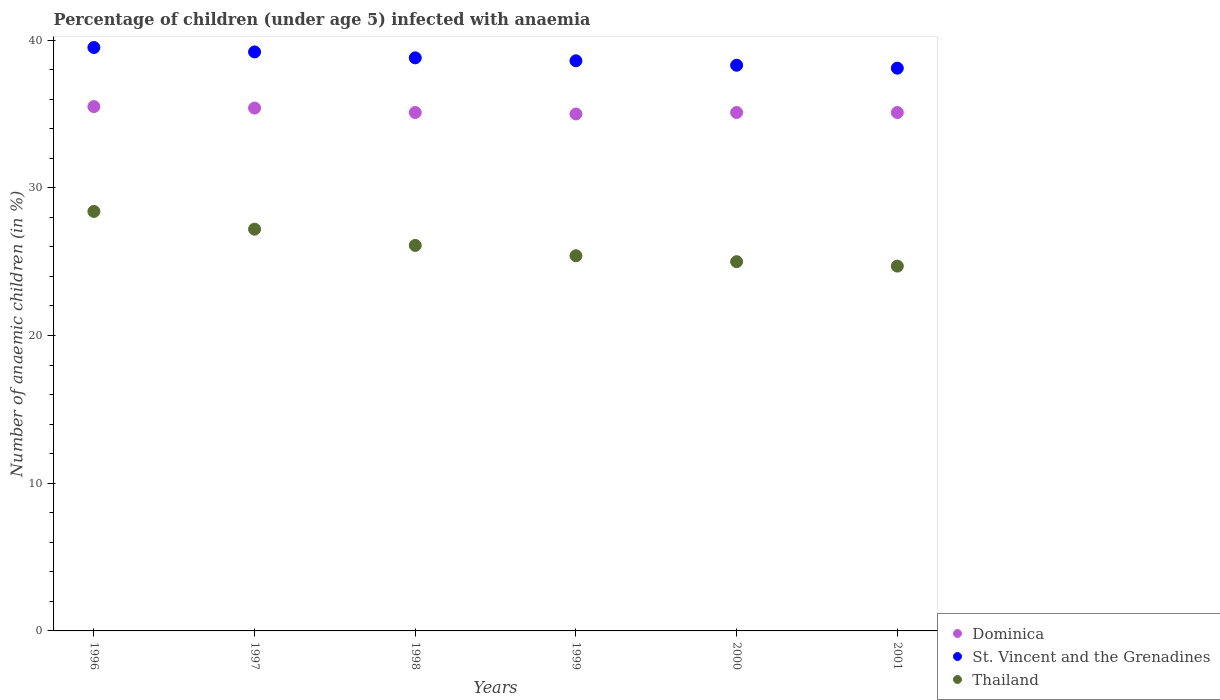How many different coloured dotlines are there?
Your answer should be very brief. 3. What is the percentage of children infected with anaemia in in Dominica in 1997?
Your response must be concise. 35.4. Across all years, what is the maximum percentage of children infected with anaemia in in St. Vincent and the Grenadines?
Your answer should be compact. 39.5. Across all years, what is the minimum percentage of children infected with anaemia in in Thailand?
Provide a succinct answer. 24.7. What is the total percentage of children infected with anaemia in in Thailand in the graph?
Offer a very short reply. 156.8. What is the difference between the percentage of children infected with anaemia in in Thailand in 1996 and that in 2001?
Give a very brief answer. 3.7. What is the difference between the percentage of children infected with anaemia in in Dominica in 1999 and the percentage of children infected with anaemia in in Thailand in 1996?
Offer a terse response. 6.6. What is the average percentage of children infected with anaemia in in St. Vincent and the Grenadines per year?
Offer a very short reply. 38.75. In the year 2001, what is the difference between the percentage of children infected with anaemia in in Thailand and percentage of children infected with anaemia in in St. Vincent and the Grenadines?
Make the answer very short. -13.4. In how many years, is the percentage of children infected with anaemia in in Dominica greater than 4 %?
Your response must be concise. 6. Is the difference between the percentage of children infected with anaemia in in Thailand in 1998 and 1999 greater than the difference between the percentage of children infected with anaemia in in St. Vincent and the Grenadines in 1998 and 1999?
Your answer should be very brief. Yes. What is the difference between the highest and the second highest percentage of children infected with anaemia in in Dominica?
Offer a very short reply. 0.1. What is the difference between the highest and the lowest percentage of children infected with anaemia in in Thailand?
Give a very brief answer. 3.7. Is the percentage of children infected with anaemia in in Thailand strictly less than the percentage of children infected with anaemia in in St. Vincent and the Grenadines over the years?
Provide a succinct answer. Yes. What is the difference between two consecutive major ticks on the Y-axis?
Give a very brief answer. 10. Are the values on the major ticks of Y-axis written in scientific E-notation?
Ensure brevity in your answer.  No. Does the graph contain any zero values?
Make the answer very short. No. Where does the legend appear in the graph?
Offer a terse response. Bottom right. How are the legend labels stacked?
Your answer should be compact. Vertical. What is the title of the graph?
Offer a very short reply. Percentage of children (under age 5) infected with anaemia. Does "Portugal" appear as one of the legend labels in the graph?
Your answer should be compact. No. What is the label or title of the Y-axis?
Offer a very short reply. Number of anaemic children (in %). What is the Number of anaemic children (in %) in Dominica in 1996?
Your answer should be compact. 35.5. What is the Number of anaemic children (in %) in St. Vincent and the Grenadines in 1996?
Provide a short and direct response. 39.5. What is the Number of anaemic children (in %) of Thailand in 1996?
Provide a short and direct response. 28.4. What is the Number of anaemic children (in %) of Dominica in 1997?
Provide a succinct answer. 35.4. What is the Number of anaemic children (in %) of St. Vincent and the Grenadines in 1997?
Your answer should be compact. 39.2. What is the Number of anaemic children (in %) of Thailand in 1997?
Provide a short and direct response. 27.2. What is the Number of anaemic children (in %) of Dominica in 1998?
Give a very brief answer. 35.1. What is the Number of anaemic children (in %) of St. Vincent and the Grenadines in 1998?
Your response must be concise. 38.8. What is the Number of anaemic children (in %) of Thailand in 1998?
Make the answer very short. 26.1. What is the Number of anaemic children (in %) of St. Vincent and the Grenadines in 1999?
Provide a succinct answer. 38.6. What is the Number of anaemic children (in %) in Thailand in 1999?
Ensure brevity in your answer.  25.4. What is the Number of anaemic children (in %) in Dominica in 2000?
Your response must be concise. 35.1. What is the Number of anaemic children (in %) of St. Vincent and the Grenadines in 2000?
Your answer should be compact. 38.3. What is the Number of anaemic children (in %) in Dominica in 2001?
Offer a terse response. 35.1. What is the Number of anaemic children (in %) in St. Vincent and the Grenadines in 2001?
Give a very brief answer. 38.1. What is the Number of anaemic children (in %) of Thailand in 2001?
Provide a succinct answer. 24.7. Across all years, what is the maximum Number of anaemic children (in %) of Dominica?
Offer a very short reply. 35.5. Across all years, what is the maximum Number of anaemic children (in %) in St. Vincent and the Grenadines?
Keep it short and to the point. 39.5. Across all years, what is the maximum Number of anaemic children (in %) in Thailand?
Your answer should be compact. 28.4. Across all years, what is the minimum Number of anaemic children (in %) of St. Vincent and the Grenadines?
Make the answer very short. 38.1. Across all years, what is the minimum Number of anaemic children (in %) in Thailand?
Your answer should be compact. 24.7. What is the total Number of anaemic children (in %) of Dominica in the graph?
Your answer should be very brief. 211.2. What is the total Number of anaemic children (in %) of St. Vincent and the Grenadines in the graph?
Provide a succinct answer. 232.5. What is the total Number of anaemic children (in %) of Thailand in the graph?
Your answer should be very brief. 156.8. What is the difference between the Number of anaemic children (in %) in Dominica in 1996 and that in 1997?
Your answer should be compact. 0.1. What is the difference between the Number of anaemic children (in %) in St. Vincent and the Grenadines in 1996 and that in 1997?
Your answer should be compact. 0.3. What is the difference between the Number of anaemic children (in %) in Thailand in 1996 and that in 1997?
Offer a very short reply. 1.2. What is the difference between the Number of anaemic children (in %) in St. Vincent and the Grenadines in 1996 and that in 1999?
Your answer should be very brief. 0.9. What is the difference between the Number of anaemic children (in %) of Thailand in 1996 and that in 1999?
Keep it short and to the point. 3. What is the difference between the Number of anaemic children (in %) of Dominica in 1996 and that in 2000?
Provide a succinct answer. 0.4. What is the difference between the Number of anaemic children (in %) in St. Vincent and the Grenadines in 1996 and that in 2000?
Offer a terse response. 1.2. What is the difference between the Number of anaemic children (in %) in Thailand in 1996 and that in 2000?
Offer a terse response. 3.4. What is the difference between the Number of anaemic children (in %) in St. Vincent and the Grenadines in 1996 and that in 2001?
Your answer should be compact. 1.4. What is the difference between the Number of anaemic children (in %) of St. Vincent and the Grenadines in 1997 and that in 1998?
Offer a terse response. 0.4. What is the difference between the Number of anaemic children (in %) in Thailand in 1997 and that in 1998?
Provide a short and direct response. 1.1. What is the difference between the Number of anaemic children (in %) of St. Vincent and the Grenadines in 1997 and that in 1999?
Offer a very short reply. 0.6. What is the difference between the Number of anaemic children (in %) of Thailand in 1997 and that in 1999?
Your answer should be very brief. 1.8. What is the difference between the Number of anaemic children (in %) of St. Vincent and the Grenadines in 1997 and that in 2000?
Give a very brief answer. 0.9. What is the difference between the Number of anaemic children (in %) of Thailand in 1997 and that in 2000?
Keep it short and to the point. 2.2. What is the difference between the Number of anaemic children (in %) of Dominica in 1997 and that in 2001?
Keep it short and to the point. 0.3. What is the difference between the Number of anaemic children (in %) of St. Vincent and the Grenadines in 1997 and that in 2001?
Give a very brief answer. 1.1. What is the difference between the Number of anaemic children (in %) of Dominica in 1998 and that in 1999?
Offer a very short reply. 0.1. What is the difference between the Number of anaemic children (in %) in St. Vincent and the Grenadines in 1998 and that in 1999?
Ensure brevity in your answer.  0.2. What is the difference between the Number of anaemic children (in %) in Thailand in 1998 and that in 1999?
Give a very brief answer. 0.7. What is the difference between the Number of anaemic children (in %) of Dominica in 1998 and that in 2000?
Offer a very short reply. 0. What is the difference between the Number of anaemic children (in %) in St. Vincent and the Grenadines in 1998 and that in 2000?
Keep it short and to the point. 0.5. What is the difference between the Number of anaemic children (in %) of Thailand in 1998 and that in 2000?
Your answer should be very brief. 1.1. What is the difference between the Number of anaemic children (in %) of Dominica in 1998 and that in 2001?
Provide a succinct answer. 0. What is the difference between the Number of anaemic children (in %) in Thailand in 1998 and that in 2001?
Your answer should be very brief. 1.4. What is the difference between the Number of anaemic children (in %) in Dominica in 1999 and that in 2000?
Keep it short and to the point. -0.1. What is the difference between the Number of anaemic children (in %) in St. Vincent and the Grenadines in 1999 and that in 2000?
Keep it short and to the point. 0.3. What is the difference between the Number of anaemic children (in %) of Thailand in 1999 and that in 2000?
Offer a very short reply. 0.4. What is the difference between the Number of anaemic children (in %) of Dominica in 1999 and that in 2001?
Offer a terse response. -0.1. What is the difference between the Number of anaemic children (in %) in Thailand in 1999 and that in 2001?
Your response must be concise. 0.7. What is the difference between the Number of anaemic children (in %) in Dominica in 2000 and that in 2001?
Make the answer very short. 0. What is the difference between the Number of anaemic children (in %) in St. Vincent and the Grenadines in 2000 and that in 2001?
Offer a terse response. 0.2. What is the difference between the Number of anaemic children (in %) in Dominica in 1996 and the Number of anaemic children (in %) in St. Vincent and the Grenadines in 1997?
Your answer should be compact. -3.7. What is the difference between the Number of anaemic children (in %) in Dominica in 1996 and the Number of anaemic children (in %) in St. Vincent and the Grenadines in 1998?
Your response must be concise. -3.3. What is the difference between the Number of anaemic children (in %) in Dominica in 1996 and the Number of anaemic children (in %) in Thailand in 1998?
Give a very brief answer. 9.4. What is the difference between the Number of anaemic children (in %) in St. Vincent and the Grenadines in 1996 and the Number of anaemic children (in %) in Thailand in 1998?
Your answer should be very brief. 13.4. What is the difference between the Number of anaemic children (in %) of Dominica in 1996 and the Number of anaemic children (in %) of St. Vincent and the Grenadines in 1999?
Your answer should be compact. -3.1. What is the difference between the Number of anaemic children (in %) of Dominica in 1996 and the Number of anaemic children (in %) of St. Vincent and the Grenadines in 2000?
Your answer should be very brief. -2.8. What is the difference between the Number of anaemic children (in %) in St. Vincent and the Grenadines in 1996 and the Number of anaemic children (in %) in Thailand in 2000?
Offer a terse response. 14.5. What is the difference between the Number of anaemic children (in %) of Dominica in 1996 and the Number of anaemic children (in %) of St. Vincent and the Grenadines in 2001?
Keep it short and to the point. -2.6. What is the difference between the Number of anaemic children (in %) of St. Vincent and the Grenadines in 1996 and the Number of anaemic children (in %) of Thailand in 2001?
Keep it short and to the point. 14.8. What is the difference between the Number of anaemic children (in %) of Dominica in 1997 and the Number of anaemic children (in %) of Thailand in 1998?
Your answer should be compact. 9.3. What is the difference between the Number of anaemic children (in %) in St. Vincent and the Grenadines in 1997 and the Number of anaemic children (in %) in Thailand in 1998?
Keep it short and to the point. 13.1. What is the difference between the Number of anaemic children (in %) in Dominica in 1997 and the Number of anaemic children (in %) in St. Vincent and the Grenadines in 1999?
Provide a succinct answer. -3.2. What is the difference between the Number of anaemic children (in %) in Dominica in 1997 and the Number of anaemic children (in %) in Thailand in 1999?
Your answer should be compact. 10. What is the difference between the Number of anaemic children (in %) of St. Vincent and the Grenadines in 1997 and the Number of anaemic children (in %) of Thailand in 1999?
Ensure brevity in your answer.  13.8. What is the difference between the Number of anaemic children (in %) in Dominica in 1997 and the Number of anaemic children (in %) in St. Vincent and the Grenadines in 2000?
Provide a succinct answer. -2.9. What is the difference between the Number of anaemic children (in %) in St. Vincent and the Grenadines in 1997 and the Number of anaemic children (in %) in Thailand in 2000?
Provide a short and direct response. 14.2. What is the difference between the Number of anaemic children (in %) of Dominica in 1997 and the Number of anaemic children (in %) of St. Vincent and the Grenadines in 2001?
Your response must be concise. -2.7. What is the difference between the Number of anaemic children (in %) in St. Vincent and the Grenadines in 1997 and the Number of anaemic children (in %) in Thailand in 2001?
Make the answer very short. 14.5. What is the difference between the Number of anaemic children (in %) of Dominica in 1998 and the Number of anaemic children (in %) of St. Vincent and the Grenadines in 1999?
Offer a terse response. -3.5. What is the difference between the Number of anaemic children (in %) in St. Vincent and the Grenadines in 1998 and the Number of anaemic children (in %) in Thailand in 2000?
Offer a terse response. 13.8. What is the difference between the Number of anaemic children (in %) of Dominica in 1998 and the Number of anaemic children (in %) of Thailand in 2001?
Make the answer very short. 10.4. What is the difference between the Number of anaemic children (in %) in Dominica in 1999 and the Number of anaemic children (in %) in Thailand in 2000?
Provide a short and direct response. 10. What is the difference between the Number of anaemic children (in %) of Dominica in 1999 and the Number of anaemic children (in %) of St. Vincent and the Grenadines in 2001?
Provide a short and direct response. -3.1. What is the difference between the Number of anaemic children (in %) in Dominica in 2000 and the Number of anaemic children (in %) in St. Vincent and the Grenadines in 2001?
Your answer should be very brief. -3. What is the difference between the Number of anaemic children (in %) in Dominica in 2000 and the Number of anaemic children (in %) in Thailand in 2001?
Keep it short and to the point. 10.4. What is the difference between the Number of anaemic children (in %) in St. Vincent and the Grenadines in 2000 and the Number of anaemic children (in %) in Thailand in 2001?
Your answer should be compact. 13.6. What is the average Number of anaemic children (in %) of Dominica per year?
Provide a short and direct response. 35.2. What is the average Number of anaemic children (in %) of St. Vincent and the Grenadines per year?
Make the answer very short. 38.75. What is the average Number of anaemic children (in %) of Thailand per year?
Provide a succinct answer. 26.13. In the year 1996, what is the difference between the Number of anaemic children (in %) of Dominica and Number of anaemic children (in %) of Thailand?
Give a very brief answer. 7.1. In the year 1997, what is the difference between the Number of anaemic children (in %) in St. Vincent and the Grenadines and Number of anaemic children (in %) in Thailand?
Your response must be concise. 12. In the year 1998, what is the difference between the Number of anaemic children (in %) of Dominica and Number of anaemic children (in %) of St. Vincent and the Grenadines?
Your response must be concise. -3.7. In the year 1999, what is the difference between the Number of anaemic children (in %) of Dominica and Number of anaemic children (in %) of Thailand?
Keep it short and to the point. 9.6. In the year 2000, what is the difference between the Number of anaemic children (in %) in Dominica and Number of anaemic children (in %) in St. Vincent and the Grenadines?
Offer a very short reply. -3.2. In the year 2000, what is the difference between the Number of anaemic children (in %) in St. Vincent and the Grenadines and Number of anaemic children (in %) in Thailand?
Your answer should be compact. 13.3. In the year 2001, what is the difference between the Number of anaemic children (in %) of Dominica and Number of anaemic children (in %) of Thailand?
Provide a short and direct response. 10.4. In the year 2001, what is the difference between the Number of anaemic children (in %) of St. Vincent and the Grenadines and Number of anaemic children (in %) of Thailand?
Your response must be concise. 13.4. What is the ratio of the Number of anaemic children (in %) of St. Vincent and the Grenadines in 1996 to that in 1997?
Ensure brevity in your answer.  1.01. What is the ratio of the Number of anaemic children (in %) in Thailand in 1996 to that in 1997?
Your answer should be compact. 1.04. What is the ratio of the Number of anaemic children (in %) of Dominica in 1996 to that in 1998?
Offer a very short reply. 1.01. What is the ratio of the Number of anaemic children (in %) in St. Vincent and the Grenadines in 1996 to that in 1998?
Make the answer very short. 1.02. What is the ratio of the Number of anaemic children (in %) of Thailand in 1996 to that in 1998?
Your response must be concise. 1.09. What is the ratio of the Number of anaemic children (in %) of Dominica in 1996 to that in 1999?
Your answer should be compact. 1.01. What is the ratio of the Number of anaemic children (in %) in St. Vincent and the Grenadines in 1996 to that in 1999?
Make the answer very short. 1.02. What is the ratio of the Number of anaemic children (in %) in Thailand in 1996 to that in 1999?
Your response must be concise. 1.12. What is the ratio of the Number of anaemic children (in %) in Dominica in 1996 to that in 2000?
Your answer should be very brief. 1.01. What is the ratio of the Number of anaemic children (in %) of St. Vincent and the Grenadines in 1996 to that in 2000?
Offer a terse response. 1.03. What is the ratio of the Number of anaemic children (in %) of Thailand in 1996 to that in 2000?
Your answer should be compact. 1.14. What is the ratio of the Number of anaemic children (in %) of Dominica in 1996 to that in 2001?
Make the answer very short. 1.01. What is the ratio of the Number of anaemic children (in %) in St. Vincent and the Grenadines in 1996 to that in 2001?
Give a very brief answer. 1.04. What is the ratio of the Number of anaemic children (in %) in Thailand in 1996 to that in 2001?
Provide a succinct answer. 1.15. What is the ratio of the Number of anaemic children (in %) in Dominica in 1997 to that in 1998?
Make the answer very short. 1.01. What is the ratio of the Number of anaemic children (in %) in St. Vincent and the Grenadines in 1997 to that in 1998?
Offer a very short reply. 1.01. What is the ratio of the Number of anaemic children (in %) in Thailand in 1997 to that in 1998?
Give a very brief answer. 1.04. What is the ratio of the Number of anaemic children (in %) of Dominica in 1997 to that in 1999?
Keep it short and to the point. 1.01. What is the ratio of the Number of anaemic children (in %) in St. Vincent and the Grenadines in 1997 to that in 1999?
Ensure brevity in your answer.  1.02. What is the ratio of the Number of anaemic children (in %) in Thailand in 1997 to that in 1999?
Your answer should be compact. 1.07. What is the ratio of the Number of anaemic children (in %) of Dominica in 1997 to that in 2000?
Your answer should be compact. 1.01. What is the ratio of the Number of anaemic children (in %) of St. Vincent and the Grenadines in 1997 to that in 2000?
Give a very brief answer. 1.02. What is the ratio of the Number of anaemic children (in %) in Thailand in 1997 to that in 2000?
Ensure brevity in your answer.  1.09. What is the ratio of the Number of anaemic children (in %) in Dominica in 1997 to that in 2001?
Your answer should be compact. 1.01. What is the ratio of the Number of anaemic children (in %) in St. Vincent and the Grenadines in 1997 to that in 2001?
Your answer should be very brief. 1.03. What is the ratio of the Number of anaemic children (in %) in Thailand in 1997 to that in 2001?
Ensure brevity in your answer.  1.1. What is the ratio of the Number of anaemic children (in %) of St. Vincent and the Grenadines in 1998 to that in 1999?
Your response must be concise. 1.01. What is the ratio of the Number of anaemic children (in %) in Thailand in 1998 to that in 1999?
Give a very brief answer. 1.03. What is the ratio of the Number of anaemic children (in %) of St. Vincent and the Grenadines in 1998 to that in 2000?
Offer a terse response. 1.01. What is the ratio of the Number of anaemic children (in %) of Thailand in 1998 to that in 2000?
Your response must be concise. 1.04. What is the ratio of the Number of anaemic children (in %) of Dominica in 1998 to that in 2001?
Make the answer very short. 1. What is the ratio of the Number of anaemic children (in %) in St. Vincent and the Grenadines in 1998 to that in 2001?
Provide a short and direct response. 1.02. What is the ratio of the Number of anaemic children (in %) of Thailand in 1998 to that in 2001?
Give a very brief answer. 1.06. What is the ratio of the Number of anaemic children (in %) of Dominica in 1999 to that in 2000?
Ensure brevity in your answer.  1. What is the ratio of the Number of anaemic children (in %) of Thailand in 1999 to that in 2000?
Your answer should be very brief. 1.02. What is the ratio of the Number of anaemic children (in %) of Dominica in 1999 to that in 2001?
Offer a terse response. 1. What is the ratio of the Number of anaemic children (in %) of St. Vincent and the Grenadines in 1999 to that in 2001?
Ensure brevity in your answer.  1.01. What is the ratio of the Number of anaemic children (in %) of Thailand in 1999 to that in 2001?
Provide a succinct answer. 1.03. What is the ratio of the Number of anaemic children (in %) of Thailand in 2000 to that in 2001?
Provide a short and direct response. 1.01. What is the difference between the highest and the second highest Number of anaemic children (in %) of St. Vincent and the Grenadines?
Offer a very short reply. 0.3. What is the difference between the highest and the second highest Number of anaemic children (in %) of Thailand?
Give a very brief answer. 1.2. What is the difference between the highest and the lowest Number of anaemic children (in %) in Dominica?
Give a very brief answer. 0.5. What is the difference between the highest and the lowest Number of anaemic children (in %) in Thailand?
Provide a succinct answer. 3.7. 